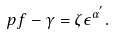Convert formula to latex. <formula><loc_0><loc_0><loc_500><loc_500>p f - \gamma = \zeta \epsilon ^ { \alpha ^ { ^ { \prime } } } .</formula> 